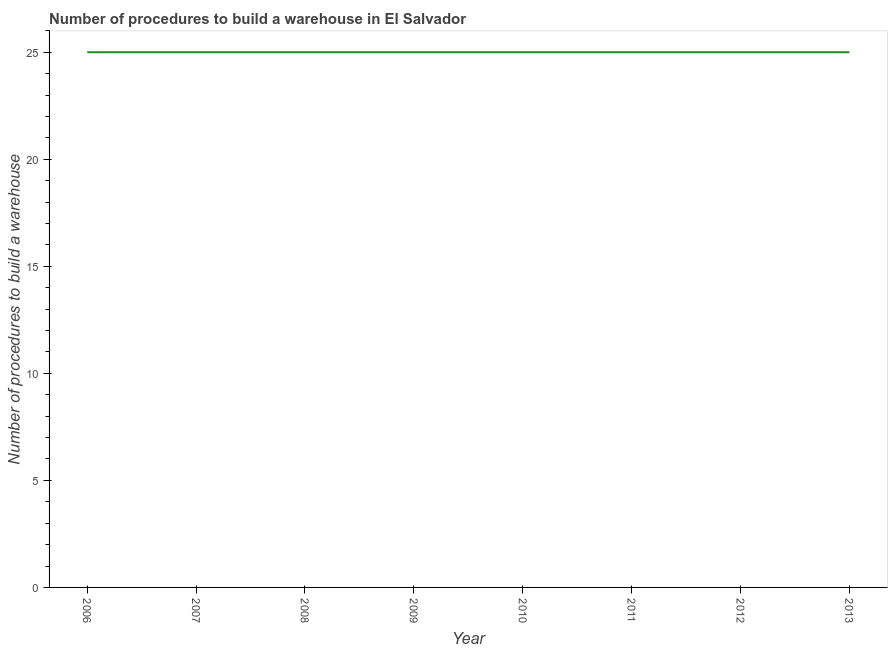What is the number of procedures to build a warehouse in 2009?
Ensure brevity in your answer.  25. Across all years, what is the maximum number of procedures to build a warehouse?
Provide a succinct answer. 25. Across all years, what is the minimum number of procedures to build a warehouse?
Offer a very short reply. 25. In which year was the number of procedures to build a warehouse maximum?
Make the answer very short. 2006. What is the sum of the number of procedures to build a warehouse?
Give a very brief answer. 200. What is the difference between the number of procedures to build a warehouse in 2011 and 2013?
Your answer should be compact. 0. What is the median number of procedures to build a warehouse?
Your answer should be very brief. 25. In how many years, is the number of procedures to build a warehouse greater than 10 ?
Ensure brevity in your answer.  8. Do a majority of the years between 2010 and 2006 (inclusive) have number of procedures to build a warehouse greater than 24 ?
Keep it short and to the point. Yes. Is the number of procedures to build a warehouse in 2009 less than that in 2012?
Give a very brief answer. No. What is the difference between the highest and the second highest number of procedures to build a warehouse?
Your answer should be very brief. 0. Is the sum of the number of procedures to build a warehouse in 2009 and 2010 greater than the maximum number of procedures to build a warehouse across all years?
Give a very brief answer. Yes. In how many years, is the number of procedures to build a warehouse greater than the average number of procedures to build a warehouse taken over all years?
Your answer should be compact. 0. How many lines are there?
Offer a very short reply. 1. What is the difference between two consecutive major ticks on the Y-axis?
Your answer should be very brief. 5. Are the values on the major ticks of Y-axis written in scientific E-notation?
Your answer should be compact. No. Does the graph contain any zero values?
Your answer should be compact. No. What is the title of the graph?
Offer a very short reply. Number of procedures to build a warehouse in El Salvador. What is the label or title of the Y-axis?
Ensure brevity in your answer.  Number of procedures to build a warehouse. What is the Number of procedures to build a warehouse of 2006?
Offer a very short reply. 25. What is the Number of procedures to build a warehouse of 2007?
Your answer should be compact. 25. What is the Number of procedures to build a warehouse of 2008?
Make the answer very short. 25. What is the Number of procedures to build a warehouse of 2009?
Keep it short and to the point. 25. What is the Number of procedures to build a warehouse in 2011?
Your answer should be compact. 25. What is the difference between the Number of procedures to build a warehouse in 2006 and 2007?
Your answer should be very brief. 0. What is the difference between the Number of procedures to build a warehouse in 2006 and 2009?
Provide a succinct answer. 0. What is the difference between the Number of procedures to build a warehouse in 2006 and 2010?
Offer a terse response. 0. What is the difference between the Number of procedures to build a warehouse in 2006 and 2011?
Your answer should be compact. 0. What is the difference between the Number of procedures to build a warehouse in 2006 and 2012?
Your answer should be very brief. 0. What is the difference between the Number of procedures to build a warehouse in 2006 and 2013?
Ensure brevity in your answer.  0. What is the difference between the Number of procedures to build a warehouse in 2007 and 2010?
Your response must be concise. 0. What is the difference between the Number of procedures to build a warehouse in 2007 and 2011?
Provide a succinct answer. 0. What is the difference between the Number of procedures to build a warehouse in 2008 and 2009?
Provide a succinct answer. 0. What is the difference between the Number of procedures to build a warehouse in 2008 and 2010?
Your answer should be compact. 0. What is the difference between the Number of procedures to build a warehouse in 2008 and 2012?
Make the answer very short. 0. What is the difference between the Number of procedures to build a warehouse in 2008 and 2013?
Provide a short and direct response. 0. What is the difference between the Number of procedures to build a warehouse in 2009 and 2011?
Your response must be concise. 0. What is the ratio of the Number of procedures to build a warehouse in 2006 to that in 2010?
Your answer should be very brief. 1. What is the ratio of the Number of procedures to build a warehouse in 2007 to that in 2008?
Give a very brief answer. 1. What is the ratio of the Number of procedures to build a warehouse in 2007 to that in 2009?
Ensure brevity in your answer.  1. What is the ratio of the Number of procedures to build a warehouse in 2007 to that in 2010?
Offer a terse response. 1. What is the ratio of the Number of procedures to build a warehouse in 2007 to that in 2011?
Your response must be concise. 1. What is the ratio of the Number of procedures to build a warehouse in 2007 to that in 2012?
Offer a terse response. 1. What is the ratio of the Number of procedures to build a warehouse in 2008 to that in 2009?
Offer a terse response. 1. What is the ratio of the Number of procedures to build a warehouse in 2008 to that in 2011?
Give a very brief answer. 1. What is the ratio of the Number of procedures to build a warehouse in 2008 to that in 2012?
Provide a succinct answer. 1. What is the ratio of the Number of procedures to build a warehouse in 2009 to that in 2012?
Make the answer very short. 1. What is the ratio of the Number of procedures to build a warehouse in 2009 to that in 2013?
Make the answer very short. 1. What is the ratio of the Number of procedures to build a warehouse in 2010 to that in 2012?
Provide a short and direct response. 1. What is the ratio of the Number of procedures to build a warehouse in 2011 to that in 2012?
Keep it short and to the point. 1. What is the ratio of the Number of procedures to build a warehouse in 2011 to that in 2013?
Provide a succinct answer. 1. What is the ratio of the Number of procedures to build a warehouse in 2012 to that in 2013?
Offer a very short reply. 1. 